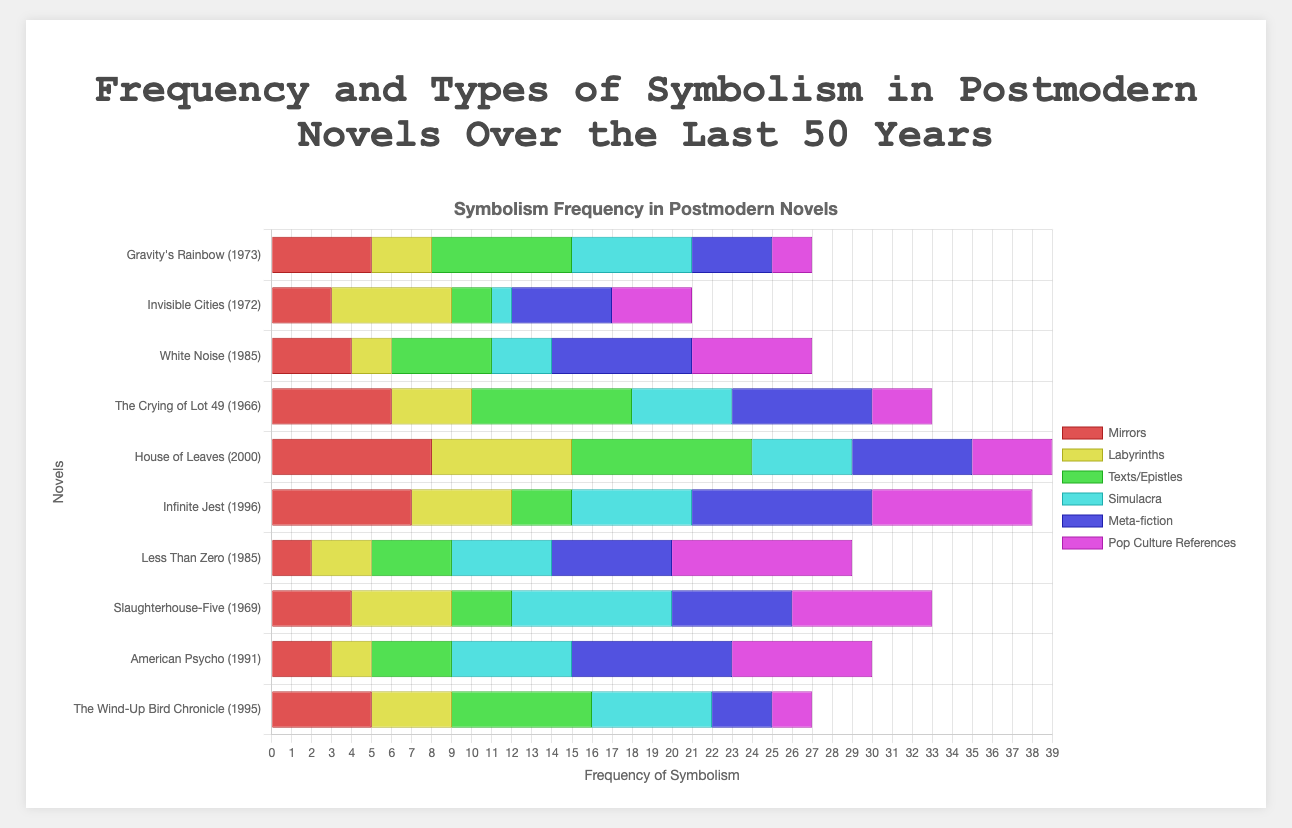Which novel shows the highest frequency of "Mirrors" symbolism? To identify the novel with the highest frequency of "Mirrors" symbolism, locate the tallest bar across the grouped bars representing "Mirrors" for each novel.
Answer: House of Leaves Which type of symbolism is the most frequently used in "Gravity's Rainbow"? On the horizontal grouped bar for "Gravity's Rainbow", identify the bar with the greatest length.
Answer: Texts/Epistles Compare the overall usage of "Labyrinths" between "Invisible Cities" and "American Psycho". Which one has a higher count? Look at the grouped bars representing "Labyrinths" for both "Invisible Cities" and "American Psycho". Measure and compare their lengths.
Answer: Invisible Cities What is the total number of "Simulacra" symbolism occurrences across all novels? Sum the frequencies of "Simulacra" across each grouped bar. The values to sum are from each novel's "Simulacra" frequency.
Answer: 51 Are there any novels where all six types of symbolism have even occurrences of 5 and above? Inspect each novel's grouped bars to check if all bars representing the six symbols are at least equal to a value of 5.
Answer: House of Leaves, Infinite Jest Which type of symbolism is least used overall in "Less Than Zero"? Find the shortest bar in the grouped bar section for "Less Than Zero".
Answer: Mirrors Rank "White Noise" in descending order of symbolism frequency for all types. List the bars for each symbol in "White Noise" from longest to shortest.
Answer: Meta-fiction, Pop Culture References, Texts/Epistles, Mirrors, Simulacra, Labyrinths What is the difference in frequency of "Meta-fiction" symbols between "The Crying of Lot 49" and "The Wind-Up Bird Chronicle"? Subtract the frequency of "Meta-fiction" in "The Wind-Up Bird Chronicle" from that in "The Crying of Lot 49".
Answer: 4 Which color represents the "Simulacra" symbolism in the chart? Identify the color of the bars that correspond to "Simulacra" in the legend.
Answer: Green Among the novels published in the 1970s, which one uses "Pop Culture References" most frequently? Compare the grouped bars for "Pop Culture References" among the 1970s novels ("Gravity's Rainbow" and "Invisible Cities") and identify the longest bar.
Answer: Invisible Cities 